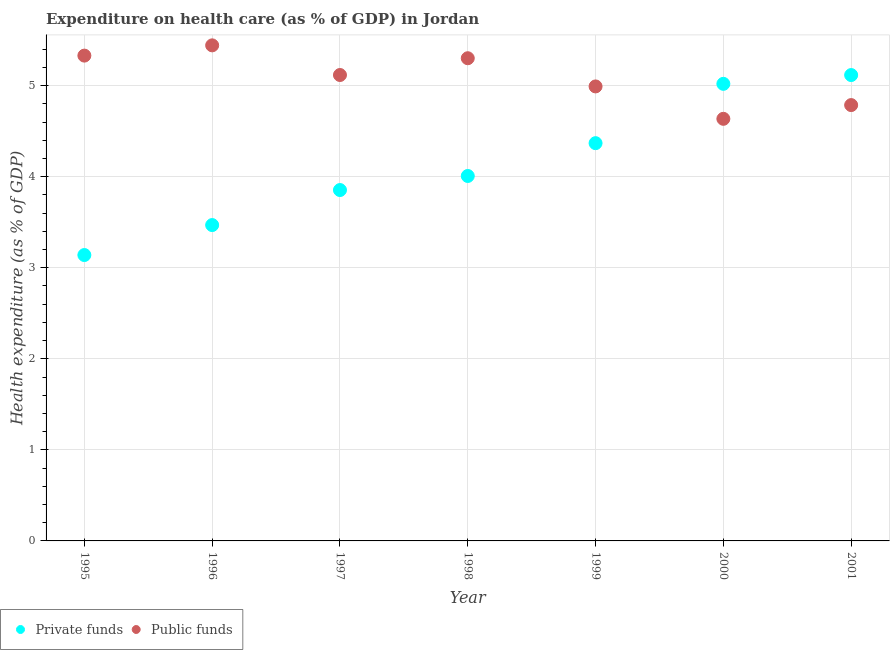How many different coloured dotlines are there?
Offer a very short reply. 2. Is the number of dotlines equal to the number of legend labels?
Make the answer very short. Yes. What is the amount of public funds spent in healthcare in 2001?
Keep it short and to the point. 4.79. Across all years, what is the maximum amount of public funds spent in healthcare?
Ensure brevity in your answer.  5.44. Across all years, what is the minimum amount of public funds spent in healthcare?
Give a very brief answer. 4.64. In which year was the amount of private funds spent in healthcare maximum?
Provide a short and direct response. 2001. What is the total amount of private funds spent in healthcare in the graph?
Keep it short and to the point. 28.97. What is the difference between the amount of private funds spent in healthcare in 1997 and that in 1998?
Offer a terse response. -0.15. What is the difference between the amount of public funds spent in healthcare in 2001 and the amount of private funds spent in healthcare in 1999?
Offer a terse response. 0.42. What is the average amount of public funds spent in healthcare per year?
Offer a terse response. 5.09. In the year 1997, what is the difference between the amount of public funds spent in healthcare and amount of private funds spent in healthcare?
Your answer should be compact. 1.26. What is the ratio of the amount of public funds spent in healthcare in 1997 to that in 2000?
Keep it short and to the point. 1.1. Is the amount of private funds spent in healthcare in 1997 less than that in 2000?
Your answer should be very brief. Yes. What is the difference between the highest and the second highest amount of private funds spent in healthcare?
Offer a very short reply. 0.1. What is the difference between the highest and the lowest amount of public funds spent in healthcare?
Provide a short and direct response. 0.81. Is the sum of the amount of private funds spent in healthcare in 1996 and 1999 greater than the maximum amount of public funds spent in healthcare across all years?
Ensure brevity in your answer.  Yes. Does the amount of public funds spent in healthcare monotonically increase over the years?
Keep it short and to the point. No. Is the amount of private funds spent in healthcare strictly less than the amount of public funds spent in healthcare over the years?
Your answer should be very brief. No. What is the difference between two consecutive major ticks on the Y-axis?
Ensure brevity in your answer.  1. Does the graph contain any zero values?
Your response must be concise. No. How many legend labels are there?
Your answer should be very brief. 2. How are the legend labels stacked?
Ensure brevity in your answer.  Horizontal. What is the title of the graph?
Offer a terse response. Expenditure on health care (as % of GDP) in Jordan. Does "Male labor force" appear as one of the legend labels in the graph?
Give a very brief answer. No. What is the label or title of the Y-axis?
Ensure brevity in your answer.  Health expenditure (as % of GDP). What is the Health expenditure (as % of GDP) of Private funds in 1995?
Provide a succinct answer. 3.14. What is the Health expenditure (as % of GDP) in Public funds in 1995?
Make the answer very short. 5.33. What is the Health expenditure (as % of GDP) of Private funds in 1996?
Offer a terse response. 3.47. What is the Health expenditure (as % of GDP) in Public funds in 1996?
Your answer should be compact. 5.44. What is the Health expenditure (as % of GDP) in Private funds in 1997?
Your response must be concise. 3.85. What is the Health expenditure (as % of GDP) of Public funds in 1997?
Offer a terse response. 5.12. What is the Health expenditure (as % of GDP) of Private funds in 1998?
Provide a short and direct response. 4.01. What is the Health expenditure (as % of GDP) in Public funds in 1998?
Keep it short and to the point. 5.3. What is the Health expenditure (as % of GDP) of Private funds in 1999?
Your response must be concise. 4.37. What is the Health expenditure (as % of GDP) in Public funds in 1999?
Offer a very short reply. 4.99. What is the Health expenditure (as % of GDP) in Private funds in 2000?
Ensure brevity in your answer.  5.02. What is the Health expenditure (as % of GDP) of Public funds in 2000?
Make the answer very short. 4.64. What is the Health expenditure (as % of GDP) in Private funds in 2001?
Provide a succinct answer. 5.12. What is the Health expenditure (as % of GDP) in Public funds in 2001?
Your answer should be very brief. 4.79. Across all years, what is the maximum Health expenditure (as % of GDP) in Private funds?
Offer a very short reply. 5.12. Across all years, what is the maximum Health expenditure (as % of GDP) in Public funds?
Offer a terse response. 5.44. Across all years, what is the minimum Health expenditure (as % of GDP) of Private funds?
Offer a very short reply. 3.14. Across all years, what is the minimum Health expenditure (as % of GDP) of Public funds?
Give a very brief answer. 4.64. What is the total Health expenditure (as % of GDP) of Private funds in the graph?
Provide a short and direct response. 28.97. What is the total Health expenditure (as % of GDP) in Public funds in the graph?
Make the answer very short. 35.6. What is the difference between the Health expenditure (as % of GDP) in Private funds in 1995 and that in 1996?
Make the answer very short. -0.33. What is the difference between the Health expenditure (as % of GDP) in Public funds in 1995 and that in 1996?
Keep it short and to the point. -0.11. What is the difference between the Health expenditure (as % of GDP) of Private funds in 1995 and that in 1997?
Your response must be concise. -0.71. What is the difference between the Health expenditure (as % of GDP) of Public funds in 1995 and that in 1997?
Make the answer very short. 0.21. What is the difference between the Health expenditure (as % of GDP) of Private funds in 1995 and that in 1998?
Provide a succinct answer. -0.87. What is the difference between the Health expenditure (as % of GDP) in Public funds in 1995 and that in 1998?
Your response must be concise. 0.03. What is the difference between the Health expenditure (as % of GDP) of Private funds in 1995 and that in 1999?
Provide a short and direct response. -1.23. What is the difference between the Health expenditure (as % of GDP) of Public funds in 1995 and that in 1999?
Offer a terse response. 0.34. What is the difference between the Health expenditure (as % of GDP) of Private funds in 1995 and that in 2000?
Keep it short and to the point. -1.88. What is the difference between the Health expenditure (as % of GDP) in Public funds in 1995 and that in 2000?
Provide a succinct answer. 0.69. What is the difference between the Health expenditure (as % of GDP) of Private funds in 1995 and that in 2001?
Provide a short and direct response. -1.98. What is the difference between the Health expenditure (as % of GDP) of Public funds in 1995 and that in 2001?
Make the answer very short. 0.54. What is the difference between the Health expenditure (as % of GDP) in Private funds in 1996 and that in 1997?
Your answer should be very brief. -0.38. What is the difference between the Health expenditure (as % of GDP) of Public funds in 1996 and that in 1997?
Ensure brevity in your answer.  0.33. What is the difference between the Health expenditure (as % of GDP) of Private funds in 1996 and that in 1998?
Give a very brief answer. -0.54. What is the difference between the Health expenditure (as % of GDP) of Public funds in 1996 and that in 1998?
Give a very brief answer. 0.14. What is the difference between the Health expenditure (as % of GDP) of Private funds in 1996 and that in 1999?
Give a very brief answer. -0.9. What is the difference between the Health expenditure (as % of GDP) of Public funds in 1996 and that in 1999?
Your answer should be compact. 0.45. What is the difference between the Health expenditure (as % of GDP) in Private funds in 1996 and that in 2000?
Your response must be concise. -1.55. What is the difference between the Health expenditure (as % of GDP) in Public funds in 1996 and that in 2000?
Provide a short and direct response. 0.81. What is the difference between the Health expenditure (as % of GDP) of Private funds in 1996 and that in 2001?
Your answer should be compact. -1.65. What is the difference between the Health expenditure (as % of GDP) of Public funds in 1996 and that in 2001?
Provide a short and direct response. 0.66. What is the difference between the Health expenditure (as % of GDP) of Private funds in 1997 and that in 1998?
Offer a terse response. -0.15. What is the difference between the Health expenditure (as % of GDP) of Public funds in 1997 and that in 1998?
Offer a terse response. -0.18. What is the difference between the Health expenditure (as % of GDP) in Private funds in 1997 and that in 1999?
Your response must be concise. -0.51. What is the difference between the Health expenditure (as % of GDP) in Public funds in 1997 and that in 1999?
Your answer should be very brief. 0.13. What is the difference between the Health expenditure (as % of GDP) in Private funds in 1997 and that in 2000?
Provide a short and direct response. -1.17. What is the difference between the Health expenditure (as % of GDP) of Public funds in 1997 and that in 2000?
Your response must be concise. 0.48. What is the difference between the Health expenditure (as % of GDP) of Private funds in 1997 and that in 2001?
Give a very brief answer. -1.26. What is the difference between the Health expenditure (as % of GDP) of Public funds in 1997 and that in 2001?
Offer a terse response. 0.33. What is the difference between the Health expenditure (as % of GDP) of Private funds in 1998 and that in 1999?
Your answer should be very brief. -0.36. What is the difference between the Health expenditure (as % of GDP) in Public funds in 1998 and that in 1999?
Offer a terse response. 0.31. What is the difference between the Health expenditure (as % of GDP) in Private funds in 1998 and that in 2000?
Your response must be concise. -1.01. What is the difference between the Health expenditure (as % of GDP) of Public funds in 1998 and that in 2000?
Your answer should be compact. 0.67. What is the difference between the Health expenditure (as % of GDP) in Private funds in 1998 and that in 2001?
Your answer should be compact. -1.11. What is the difference between the Health expenditure (as % of GDP) in Public funds in 1998 and that in 2001?
Your response must be concise. 0.51. What is the difference between the Health expenditure (as % of GDP) in Private funds in 1999 and that in 2000?
Offer a terse response. -0.65. What is the difference between the Health expenditure (as % of GDP) in Public funds in 1999 and that in 2000?
Make the answer very short. 0.36. What is the difference between the Health expenditure (as % of GDP) of Private funds in 1999 and that in 2001?
Give a very brief answer. -0.75. What is the difference between the Health expenditure (as % of GDP) of Public funds in 1999 and that in 2001?
Provide a succinct answer. 0.2. What is the difference between the Health expenditure (as % of GDP) in Private funds in 2000 and that in 2001?
Your response must be concise. -0.1. What is the difference between the Health expenditure (as % of GDP) in Public funds in 2000 and that in 2001?
Offer a terse response. -0.15. What is the difference between the Health expenditure (as % of GDP) in Private funds in 1995 and the Health expenditure (as % of GDP) in Public funds in 1996?
Provide a succinct answer. -2.3. What is the difference between the Health expenditure (as % of GDP) of Private funds in 1995 and the Health expenditure (as % of GDP) of Public funds in 1997?
Provide a short and direct response. -1.98. What is the difference between the Health expenditure (as % of GDP) in Private funds in 1995 and the Health expenditure (as % of GDP) in Public funds in 1998?
Your answer should be compact. -2.16. What is the difference between the Health expenditure (as % of GDP) in Private funds in 1995 and the Health expenditure (as % of GDP) in Public funds in 1999?
Offer a terse response. -1.85. What is the difference between the Health expenditure (as % of GDP) in Private funds in 1995 and the Health expenditure (as % of GDP) in Public funds in 2000?
Make the answer very short. -1.5. What is the difference between the Health expenditure (as % of GDP) of Private funds in 1995 and the Health expenditure (as % of GDP) of Public funds in 2001?
Provide a succinct answer. -1.65. What is the difference between the Health expenditure (as % of GDP) of Private funds in 1996 and the Health expenditure (as % of GDP) of Public funds in 1997?
Ensure brevity in your answer.  -1.65. What is the difference between the Health expenditure (as % of GDP) of Private funds in 1996 and the Health expenditure (as % of GDP) of Public funds in 1998?
Keep it short and to the point. -1.83. What is the difference between the Health expenditure (as % of GDP) in Private funds in 1996 and the Health expenditure (as % of GDP) in Public funds in 1999?
Make the answer very short. -1.52. What is the difference between the Health expenditure (as % of GDP) in Private funds in 1996 and the Health expenditure (as % of GDP) in Public funds in 2000?
Provide a succinct answer. -1.17. What is the difference between the Health expenditure (as % of GDP) of Private funds in 1996 and the Health expenditure (as % of GDP) of Public funds in 2001?
Keep it short and to the point. -1.32. What is the difference between the Health expenditure (as % of GDP) of Private funds in 1997 and the Health expenditure (as % of GDP) of Public funds in 1998?
Ensure brevity in your answer.  -1.45. What is the difference between the Health expenditure (as % of GDP) of Private funds in 1997 and the Health expenditure (as % of GDP) of Public funds in 1999?
Ensure brevity in your answer.  -1.14. What is the difference between the Health expenditure (as % of GDP) in Private funds in 1997 and the Health expenditure (as % of GDP) in Public funds in 2000?
Make the answer very short. -0.78. What is the difference between the Health expenditure (as % of GDP) of Private funds in 1997 and the Health expenditure (as % of GDP) of Public funds in 2001?
Your response must be concise. -0.93. What is the difference between the Health expenditure (as % of GDP) in Private funds in 1998 and the Health expenditure (as % of GDP) in Public funds in 1999?
Your answer should be very brief. -0.98. What is the difference between the Health expenditure (as % of GDP) of Private funds in 1998 and the Health expenditure (as % of GDP) of Public funds in 2000?
Give a very brief answer. -0.63. What is the difference between the Health expenditure (as % of GDP) in Private funds in 1998 and the Health expenditure (as % of GDP) in Public funds in 2001?
Offer a terse response. -0.78. What is the difference between the Health expenditure (as % of GDP) of Private funds in 1999 and the Health expenditure (as % of GDP) of Public funds in 2000?
Make the answer very short. -0.27. What is the difference between the Health expenditure (as % of GDP) in Private funds in 1999 and the Health expenditure (as % of GDP) in Public funds in 2001?
Ensure brevity in your answer.  -0.42. What is the difference between the Health expenditure (as % of GDP) in Private funds in 2000 and the Health expenditure (as % of GDP) in Public funds in 2001?
Your answer should be compact. 0.23. What is the average Health expenditure (as % of GDP) in Private funds per year?
Your response must be concise. 4.14. What is the average Health expenditure (as % of GDP) of Public funds per year?
Your answer should be very brief. 5.09. In the year 1995, what is the difference between the Health expenditure (as % of GDP) in Private funds and Health expenditure (as % of GDP) in Public funds?
Offer a very short reply. -2.19. In the year 1996, what is the difference between the Health expenditure (as % of GDP) of Private funds and Health expenditure (as % of GDP) of Public funds?
Ensure brevity in your answer.  -1.97. In the year 1997, what is the difference between the Health expenditure (as % of GDP) in Private funds and Health expenditure (as % of GDP) in Public funds?
Your answer should be compact. -1.26. In the year 1998, what is the difference between the Health expenditure (as % of GDP) in Private funds and Health expenditure (as % of GDP) in Public funds?
Offer a very short reply. -1.29. In the year 1999, what is the difference between the Health expenditure (as % of GDP) of Private funds and Health expenditure (as % of GDP) of Public funds?
Provide a succinct answer. -0.62. In the year 2000, what is the difference between the Health expenditure (as % of GDP) of Private funds and Health expenditure (as % of GDP) of Public funds?
Your answer should be very brief. 0.38. In the year 2001, what is the difference between the Health expenditure (as % of GDP) in Private funds and Health expenditure (as % of GDP) in Public funds?
Provide a short and direct response. 0.33. What is the ratio of the Health expenditure (as % of GDP) of Private funds in 1995 to that in 1996?
Offer a terse response. 0.91. What is the ratio of the Health expenditure (as % of GDP) in Public funds in 1995 to that in 1996?
Make the answer very short. 0.98. What is the ratio of the Health expenditure (as % of GDP) in Private funds in 1995 to that in 1997?
Your answer should be compact. 0.81. What is the ratio of the Health expenditure (as % of GDP) of Public funds in 1995 to that in 1997?
Your answer should be very brief. 1.04. What is the ratio of the Health expenditure (as % of GDP) of Private funds in 1995 to that in 1998?
Give a very brief answer. 0.78. What is the ratio of the Health expenditure (as % of GDP) in Public funds in 1995 to that in 1998?
Ensure brevity in your answer.  1.01. What is the ratio of the Health expenditure (as % of GDP) of Private funds in 1995 to that in 1999?
Offer a terse response. 0.72. What is the ratio of the Health expenditure (as % of GDP) of Public funds in 1995 to that in 1999?
Your answer should be compact. 1.07. What is the ratio of the Health expenditure (as % of GDP) in Private funds in 1995 to that in 2000?
Ensure brevity in your answer.  0.63. What is the ratio of the Health expenditure (as % of GDP) in Public funds in 1995 to that in 2000?
Offer a terse response. 1.15. What is the ratio of the Health expenditure (as % of GDP) in Private funds in 1995 to that in 2001?
Ensure brevity in your answer.  0.61. What is the ratio of the Health expenditure (as % of GDP) of Public funds in 1995 to that in 2001?
Provide a short and direct response. 1.11. What is the ratio of the Health expenditure (as % of GDP) of Private funds in 1996 to that in 1997?
Make the answer very short. 0.9. What is the ratio of the Health expenditure (as % of GDP) of Public funds in 1996 to that in 1997?
Offer a very short reply. 1.06. What is the ratio of the Health expenditure (as % of GDP) in Private funds in 1996 to that in 1998?
Your response must be concise. 0.87. What is the ratio of the Health expenditure (as % of GDP) of Public funds in 1996 to that in 1998?
Your answer should be very brief. 1.03. What is the ratio of the Health expenditure (as % of GDP) in Private funds in 1996 to that in 1999?
Offer a terse response. 0.79. What is the ratio of the Health expenditure (as % of GDP) of Public funds in 1996 to that in 1999?
Provide a succinct answer. 1.09. What is the ratio of the Health expenditure (as % of GDP) of Private funds in 1996 to that in 2000?
Provide a short and direct response. 0.69. What is the ratio of the Health expenditure (as % of GDP) in Public funds in 1996 to that in 2000?
Keep it short and to the point. 1.17. What is the ratio of the Health expenditure (as % of GDP) of Private funds in 1996 to that in 2001?
Give a very brief answer. 0.68. What is the ratio of the Health expenditure (as % of GDP) in Public funds in 1996 to that in 2001?
Provide a succinct answer. 1.14. What is the ratio of the Health expenditure (as % of GDP) in Private funds in 1997 to that in 1998?
Provide a short and direct response. 0.96. What is the ratio of the Health expenditure (as % of GDP) of Public funds in 1997 to that in 1998?
Your answer should be very brief. 0.97. What is the ratio of the Health expenditure (as % of GDP) of Private funds in 1997 to that in 1999?
Your answer should be compact. 0.88. What is the ratio of the Health expenditure (as % of GDP) in Public funds in 1997 to that in 1999?
Ensure brevity in your answer.  1.03. What is the ratio of the Health expenditure (as % of GDP) in Private funds in 1997 to that in 2000?
Your answer should be compact. 0.77. What is the ratio of the Health expenditure (as % of GDP) in Public funds in 1997 to that in 2000?
Keep it short and to the point. 1.1. What is the ratio of the Health expenditure (as % of GDP) in Private funds in 1997 to that in 2001?
Give a very brief answer. 0.75. What is the ratio of the Health expenditure (as % of GDP) in Public funds in 1997 to that in 2001?
Give a very brief answer. 1.07. What is the ratio of the Health expenditure (as % of GDP) of Private funds in 1998 to that in 1999?
Provide a succinct answer. 0.92. What is the ratio of the Health expenditure (as % of GDP) of Public funds in 1998 to that in 1999?
Offer a terse response. 1.06. What is the ratio of the Health expenditure (as % of GDP) in Private funds in 1998 to that in 2000?
Give a very brief answer. 0.8. What is the ratio of the Health expenditure (as % of GDP) of Public funds in 1998 to that in 2000?
Offer a terse response. 1.14. What is the ratio of the Health expenditure (as % of GDP) in Private funds in 1998 to that in 2001?
Offer a terse response. 0.78. What is the ratio of the Health expenditure (as % of GDP) in Public funds in 1998 to that in 2001?
Ensure brevity in your answer.  1.11. What is the ratio of the Health expenditure (as % of GDP) in Private funds in 1999 to that in 2000?
Provide a succinct answer. 0.87. What is the ratio of the Health expenditure (as % of GDP) in Public funds in 1999 to that in 2000?
Make the answer very short. 1.08. What is the ratio of the Health expenditure (as % of GDP) of Private funds in 1999 to that in 2001?
Offer a terse response. 0.85. What is the ratio of the Health expenditure (as % of GDP) of Public funds in 1999 to that in 2001?
Ensure brevity in your answer.  1.04. What is the ratio of the Health expenditure (as % of GDP) in Private funds in 2000 to that in 2001?
Provide a succinct answer. 0.98. What is the ratio of the Health expenditure (as % of GDP) of Public funds in 2000 to that in 2001?
Keep it short and to the point. 0.97. What is the difference between the highest and the second highest Health expenditure (as % of GDP) of Private funds?
Your response must be concise. 0.1. What is the difference between the highest and the second highest Health expenditure (as % of GDP) in Public funds?
Offer a very short reply. 0.11. What is the difference between the highest and the lowest Health expenditure (as % of GDP) in Private funds?
Give a very brief answer. 1.98. What is the difference between the highest and the lowest Health expenditure (as % of GDP) of Public funds?
Keep it short and to the point. 0.81. 